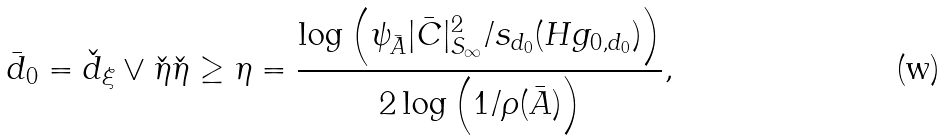Convert formula to latex. <formula><loc_0><loc_0><loc_500><loc_500>\bar { d } _ { 0 } = \check { d } _ { \xi } \vee \check { \eta } \check { \eta } \geq \eta = \frac { \log \left ( \psi _ { \bar { A } } | \bar { C } | _ { S _ { \infty } } ^ { 2 } / s _ { d _ { 0 } } ( H g _ { 0 , d _ { 0 } } ) \right ) } { 2 \log \left ( 1 / \rho ( \bar { A } ) \right ) } ,</formula> 